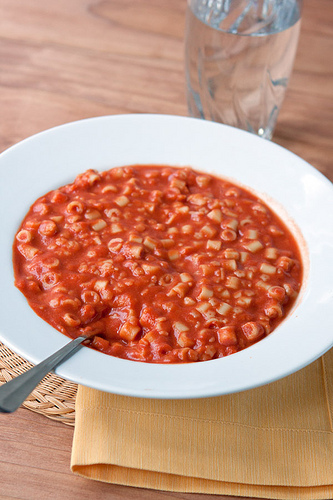<image>
Is the spoon on the bowl? Yes. Looking at the image, I can see the spoon is positioned on top of the bowl, with the bowl providing support. Where is the glass in relation to the dish? Is it behind the dish? Yes. From this viewpoint, the glass is positioned behind the dish, with the dish partially or fully occluding the glass. 